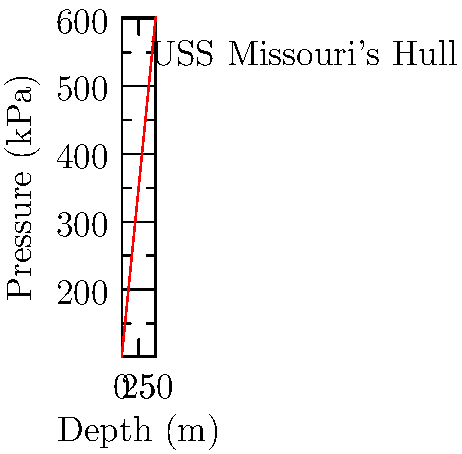During World War II, President Truman was deeply concerned about the safety of naval vessels. Consider the pressure distribution inside the hull of the USS Missouri, a ship that would later host Japan's surrender. Given the graph showing pressure vs. depth for a naval ship's hull, calculate the rate of pressure increase with depth. What would be the pressure at a depth of 45 meters? Let's approach this step-by-step:

1. Rate of pressure increase:
   - We can calculate this using two points on the line.
   - At 0m: $P_1 = 101.325$ kPa
   - At 50m: $P_2 = 601.325$ kPa
   
   Rate = $\frac{\Delta P}{\Delta d} = \frac{P_2 - P_1}{d_2 - d_1} = \frac{601.325 - 101.325}{50 - 0} = \frac{500}{50} = 10$ kPa/m

2. Pressure at 45m:
   - We can use the rate we just calculated.
   - Pressure increase = Rate × Depth = $10 \times 45 = 450$ kPa
   - Add this to the surface pressure: $101.325 + 450 = 551.325$ kPa

Therefore, at a depth of 45 meters, the pressure would be 551.325 kPa.

This knowledge would have been crucial for ensuring the structural integrity of ships like the USS Missouri, which played a significant role in President Truman's wartime strategy and post-war diplomacy.
Answer: 551.325 kPa 